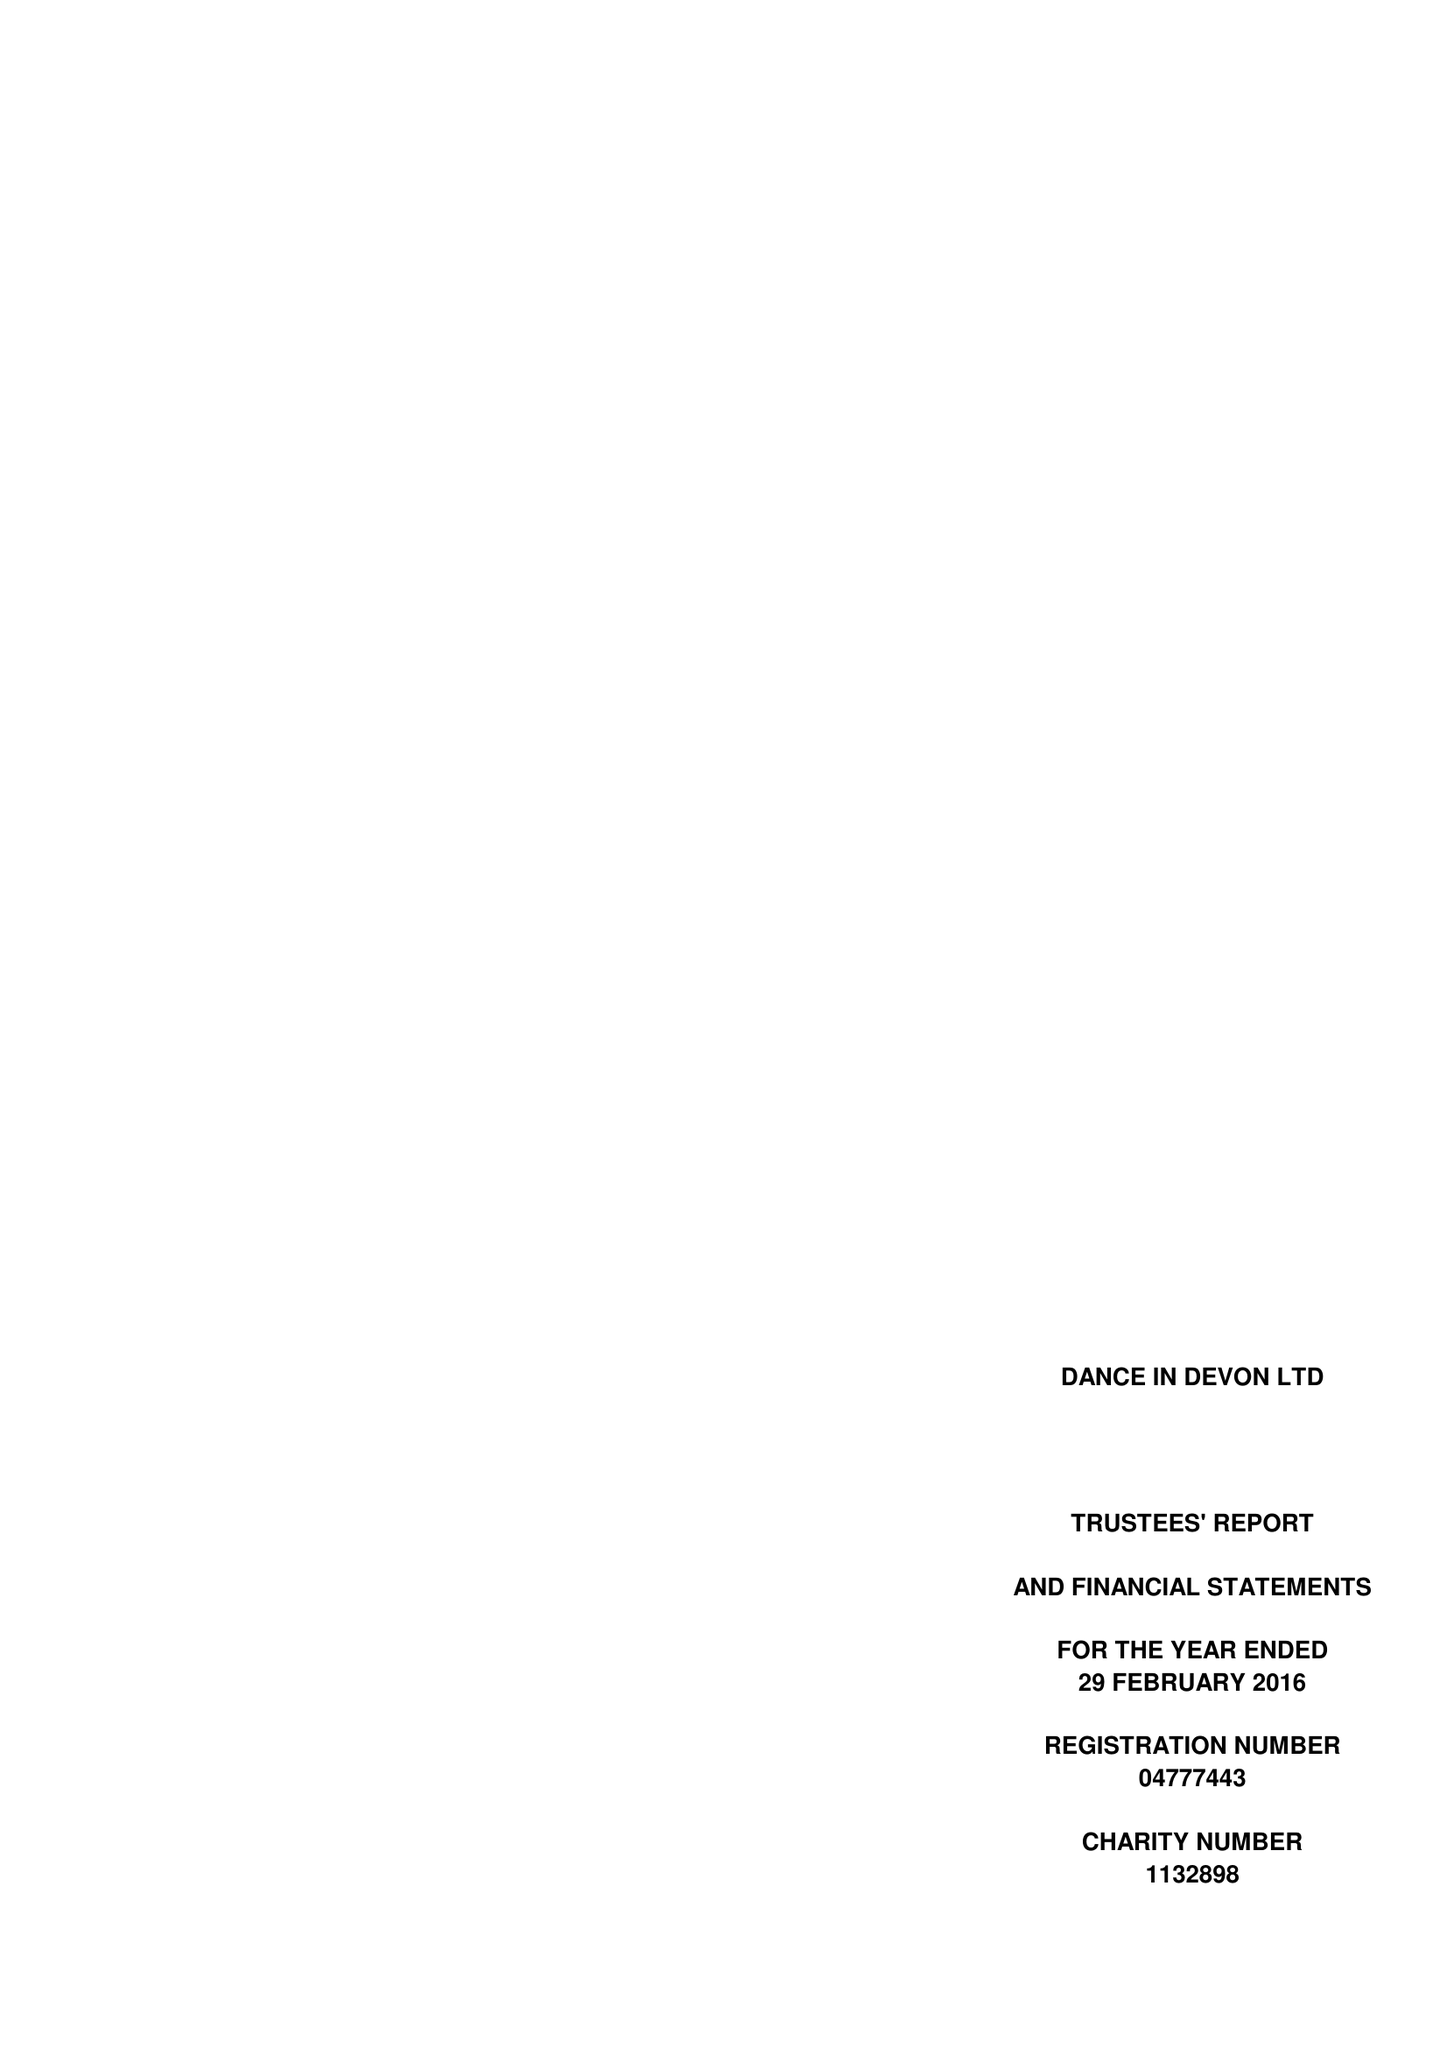What is the value for the address__postcode?
Answer the question using a single word or phrase. TQ9 6EN 